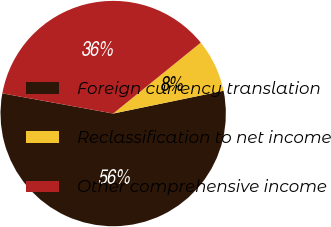Convert chart. <chart><loc_0><loc_0><loc_500><loc_500><pie_chart><fcel>Foreign currency translation<fcel>Reclassification to net income<fcel>Other comprehensive income<nl><fcel>56.11%<fcel>7.59%<fcel>36.3%<nl></chart> 